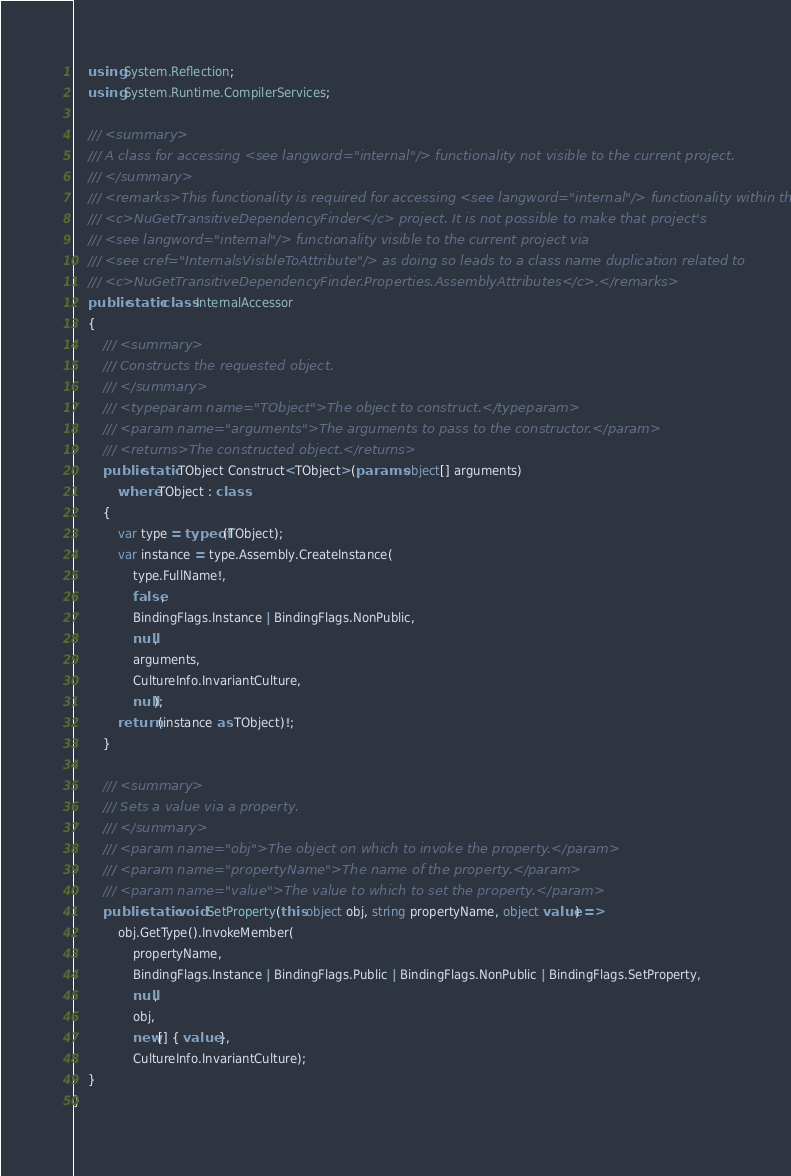Convert code to text. <code><loc_0><loc_0><loc_500><loc_500><_C#_>    using System.Reflection;
    using System.Runtime.CompilerServices;

    /// <summary>
    /// A class for accessing <see langword="internal"/> functionality not visible to the current project.
    /// </summary>
    /// <remarks>This functionality is required for accessing <see langword="internal"/> functionality within the
    /// <c>NuGetTransitiveDependencyFinder</c> project. It is not possible to make that project's
    /// <see langword="internal"/> functionality visible to the current project via
    /// <see cref="InternalsVisibleToAttribute"/> as doing so leads to a class name duplication related to
    /// <c>NuGetTransitiveDependencyFinder.Properties.AssemblyAttributes</c>.</remarks>
    public static class InternalAccessor
    {
        /// <summary>
        /// Constructs the requested object.
        /// </summary>
        /// <typeparam name="TObject">The object to construct.</typeparam>
        /// <param name="arguments">The arguments to pass to the constructor.</param>
        /// <returns>The constructed object.</returns>
        public static TObject Construct<TObject>(params object[] arguments)
            where TObject : class
        {
            var type = typeof(TObject);
            var instance = type.Assembly.CreateInstance(
                type.FullName!,
                false,
                BindingFlags.Instance | BindingFlags.NonPublic,
                null,
                arguments,
                CultureInfo.InvariantCulture,
                null);
            return (instance as TObject)!;
        }

        /// <summary>
        /// Sets a value via a property.
        /// </summary>
        /// <param name="obj">The object on which to invoke the property.</param>
        /// <param name="propertyName">The name of the property.</param>
        /// <param name="value">The value to which to set the property.</param>
        public static void SetProperty(this object obj, string propertyName, object value) =>
            obj.GetType().InvokeMember(
                propertyName,
                BindingFlags.Instance | BindingFlags.Public | BindingFlags.NonPublic | BindingFlags.SetProperty,
                null,
                obj,
                new[] { value },
                CultureInfo.InvariantCulture);
    }
}
</code> 